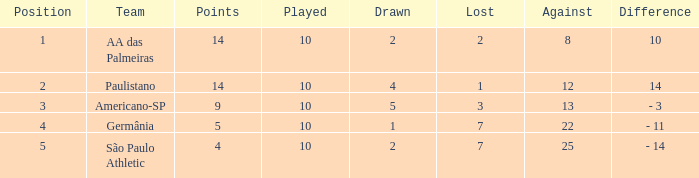What is the highest Drawn when the lost is 7 and the points are more than 4, and the against is less than 22? None. 